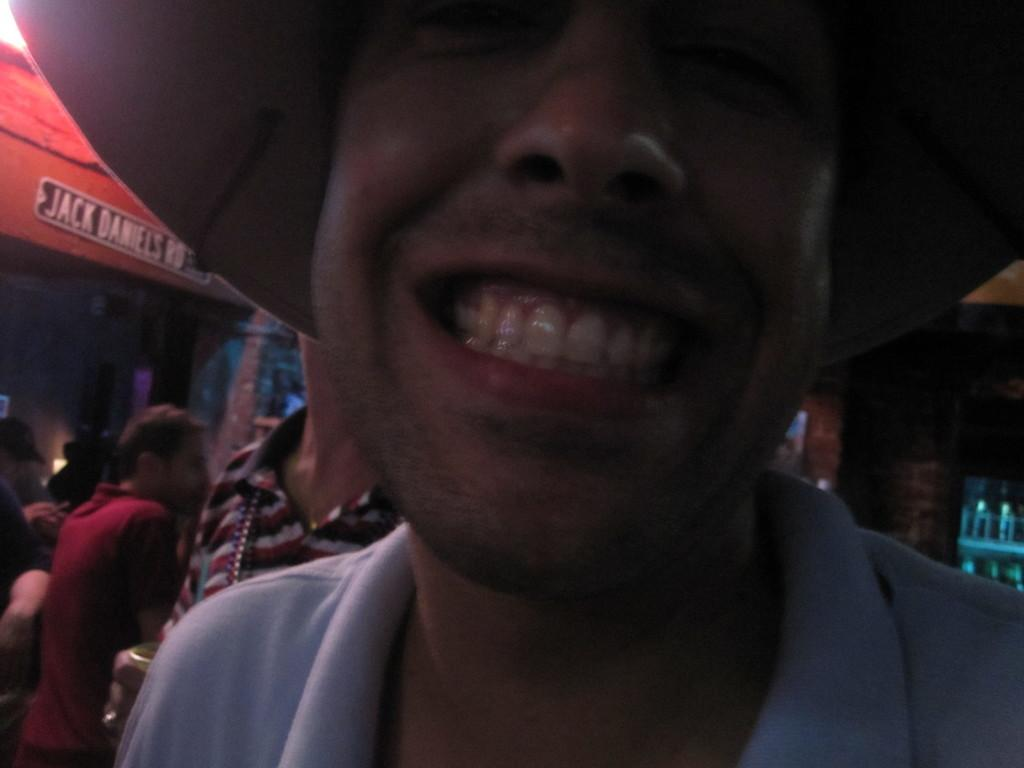What is the main subject of the image? There is a person in the image. What is the person doing in the image? The person is showing their teeth. What can be seen in the background of the image? There are people standing near a shop in the background of the image. What type of cart is the queen riding in the image? There is no cart or queen present in the image. How does the person in the image fall down? The person in the image is not falling down; they are showing their teeth. 